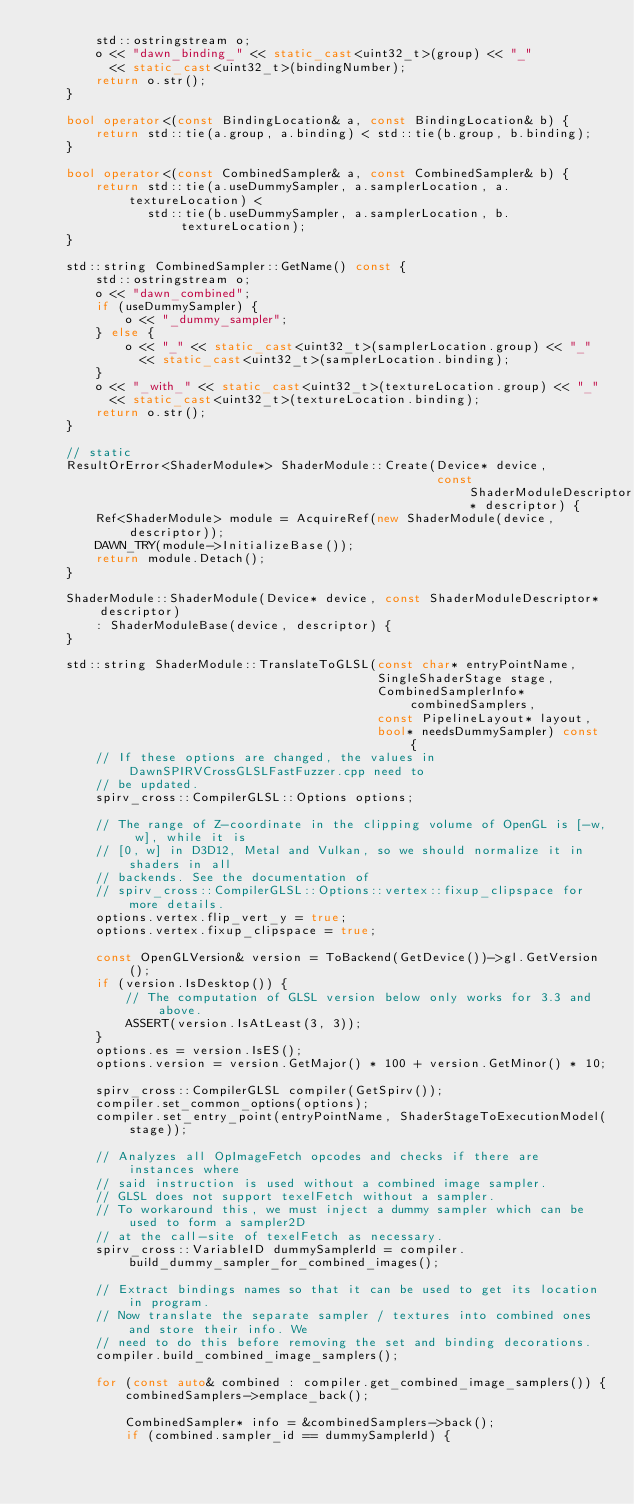Convert code to text. <code><loc_0><loc_0><loc_500><loc_500><_C++_>        std::ostringstream o;
        o << "dawn_binding_" << static_cast<uint32_t>(group) << "_"
          << static_cast<uint32_t>(bindingNumber);
        return o.str();
    }

    bool operator<(const BindingLocation& a, const BindingLocation& b) {
        return std::tie(a.group, a.binding) < std::tie(b.group, b.binding);
    }

    bool operator<(const CombinedSampler& a, const CombinedSampler& b) {
        return std::tie(a.useDummySampler, a.samplerLocation, a.textureLocation) <
               std::tie(b.useDummySampler, a.samplerLocation, b.textureLocation);
    }

    std::string CombinedSampler::GetName() const {
        std::ostringstream o;
        o << "dawn_combined";
        if (useDummySampler) {
            o << "_dummy_sampler";
        } else {
            o << "_" << static_cast<uint32_t>(samplerLocation.group) << "_"
              << static_cast<uint32_t>(samplerLocation.binding);
        }
        o << "_with_" << static_cast<uint32_t>(textureLocation.group) << "_"
          << static_cast<uint32_t>(textureLocation.binding);
        return o.str();
    }

    // static
    ResultOrError<ShaderModule*> ShaderModule::Create(Device* device,
                                                      const ShaderModuleDescriptor* descriptor) {
        Ref<ShaderModule> module = AcquireRef(new ShaderModule(device, descriptor));
        DAWN_TRY(module->InitializeBase());
        return module.Detach();
    }

    ShaderModule::ShaderModule(Device* device, const ShaderModuleDescriptor* descriptor)
        : ShaderModuleBase(device, descriptor) {
    }

    std::string ShaderModule::TranslateToGLSL(const char* entryPointName,
                                              SingleShaderStage stage,
                                              CombinedSamplerInfo* combinedSamplers,
                                              const PipelineLayout* layout,
                                              bool* needsDummySampler) const {
        // If these options are changed, the values in DawnSPIRVCrossGLSLFastFuzzer.cpp need to
        // be updated.
        spirv_cross::CompilerGLSL::Options options;

        // The range of Z-coordinate in the clipping volume of OpenGL is [-w, w], while it is
        // [0, w] in D3D12, Metal and Vulkan, so we should normalize it in shaders in all
        // backends. See the documentation of
        // spirv_cross::CompilerGLSL::Options::vertex::fixup_clipspace for more details.
        options.vertex.flip_vert_y = true;
        options.vertex.fixup_clipspace = true;

        const OpenGLVersion& version = ToBackend(GetDevice())->gl.GetVersion();
        if (version.IsDesktop()) {
            // The computation of GLSL version below only works for 3.3 and above.
            ASSERT(version.IsAtLeast(3, 3));
        }
        options.es = version.IsES();
        options.version = version.GetMajor() * 100 + version.GetMinor() * 10;

        spirv_cross::CompilerGLSL compiler(GetSpirv());
        compiler.set_common_options(options);
        compiler.set_entry_point(entryPointName, ShaderStageToExecutionModel(stage));

        // Analyzes all OpImageFetch opcodes and checks if there are instances where
        // said instruction is used without a combined image sampler.
        // GLSL does not support texelFetch without a sampler.
        // To workaround this, we must inject a dummy sampler which can be used to form a sampler2D
        // at the call-site of texelFetch as necessary.
        spirv_cross::VariableID dummySamplerId = compiler.build_dummy_sampler_for_combined_images();

        // Extract bindings names so that it can be used to get its location in program.
        // Now translate the separate sampler / textures into combined ones and store their info. We
        // need to do this before removing the set and binding decorations.
        compiler.build_combined_image_samplers();

        for (const auto& combined : compiler.get_combined_image_samplers()) {
            combinedSamplers->emplace_back();

            CombinedSampler* info = &combinedSamplers->back();
            if (combined.sampler_id == dummySamplerId) {</code> 